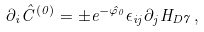<formula> <loc_0><loc_0><loc_500><loc_500>\partial _ { i } \hat { C } ^ { ( 0 ) } = \pm e ^ { - \hat { \varphi } _ { 0 } } \epsilon _ { i j } \partial _ { j } H _ { D 7 } \, ,</formula> 